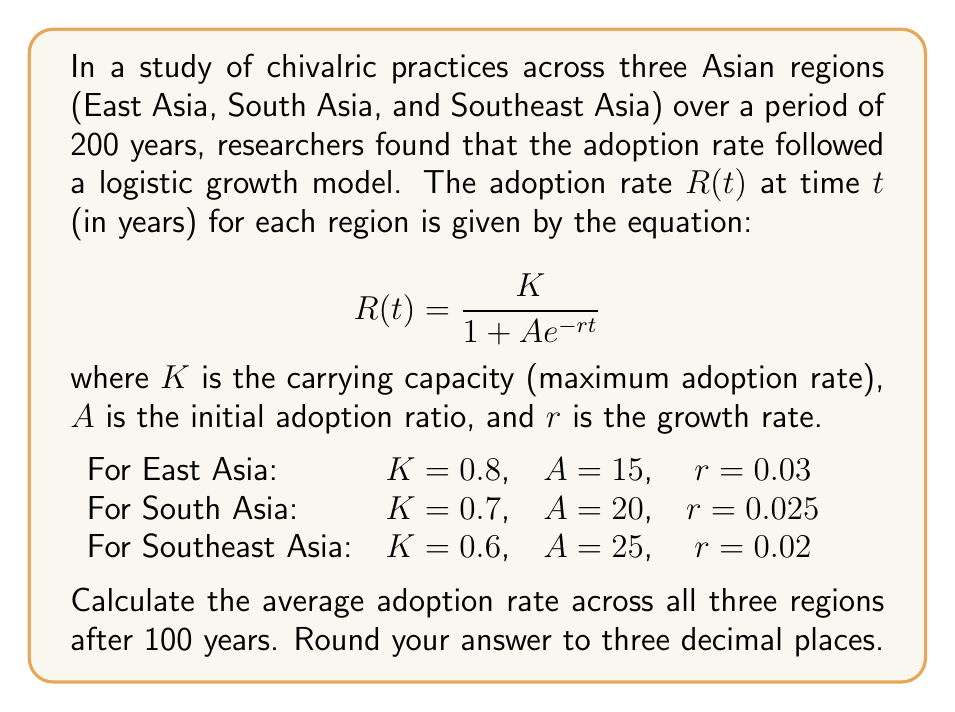Could you help me with this problem? To solve this problem, we need to follow these steps:

1. Calculate the adoption rate for each region after 100 years using the given logistic growth model.
2. Find the average of these three rates.

Let's start with each region:

1. East Asia:
   $R_{EA}(100) = \frac{0.8}{1 + 15e^{-0.03 \cdot 100}}$
   
   $= \frac{0.8}{1 + 15e^{-3}}$
   
   $= \frac{0.8}{1 + 15 \cdot 0.0497871}$
   
   $= \frac{0.8}{1.7468065} = 0.4579$

2. South Asia:
   $R_{SA}(100) = \frac{0.7}{1 + 20e^{-0.025 \cdot 100}}$
   
   $= \frac{0.7}{1 + 20e^{-2.5}}$
   
   $= \frac{0.7}{1 + 20 \cdot 0.0820850}$
   
   $= \frac{0.7}{2.6417} = 0.2649$

3. Southeast Asia:
   $R_{SEA}(100) = \frac{0.6}{1 + 25e^{-0.02 \cdot 100}}$
   
   $= \frac{0.6}{1 + 25e^{-2}}$
   
   $= \frac{0.6}{1 + 25 \cdot 0.1353353}$
   
   $= \frac{0.6}{4.3833825} = 0.1369$

Now, we calculate the average of these three rates:

$\text{Average Rate} = \frac{R_{EA}(100) + R_{SA}(100) + R_{SEA}(100)}{3}$

$= \frac{0.4579 + 0.2649 + 0.1369}{3}$

$= \frac{0.8597}{3} = 0.2866$

Rounding to three decimal places, we get 0.287.
Answer: 0.287 